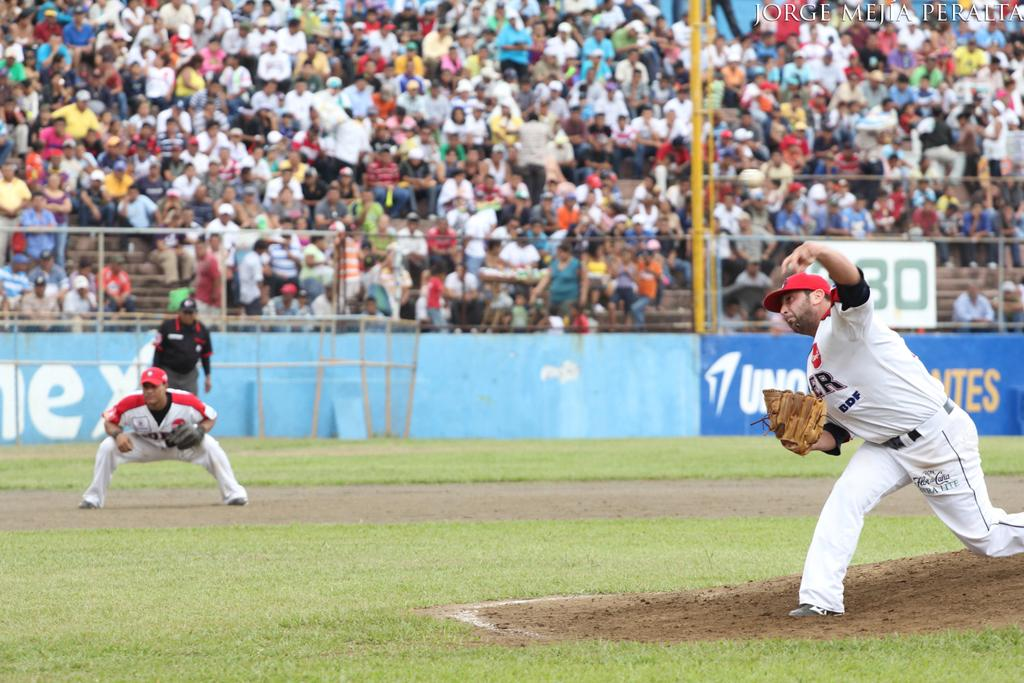<image>
Share a concise interpretation of the image provided. A baseball game is underway and a packed crowd is watching from the bleachers which have an ad for Uno. 